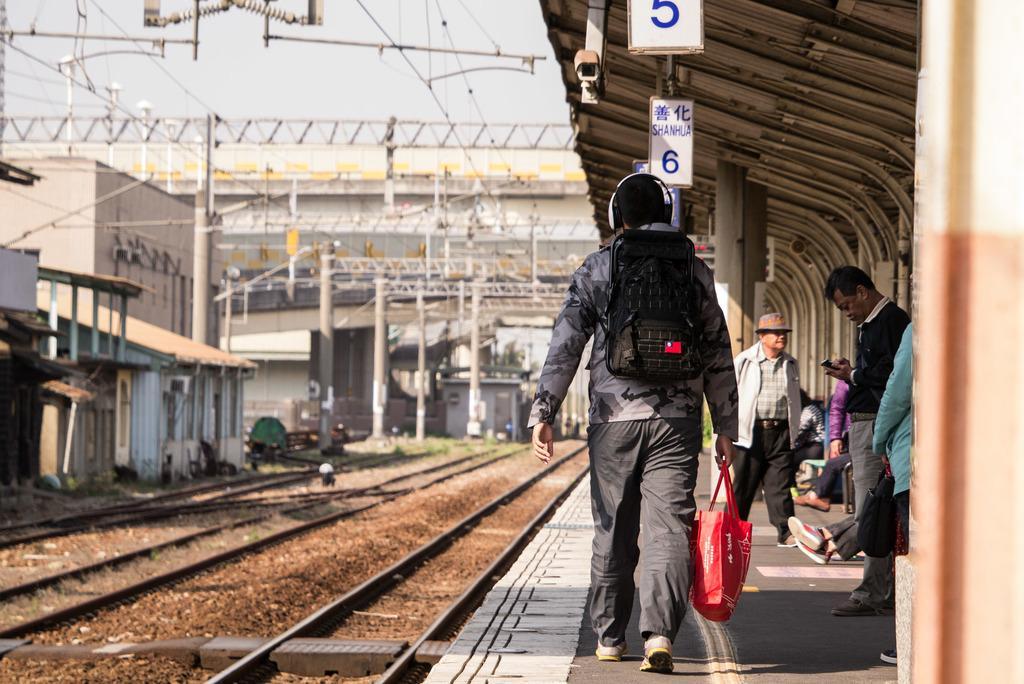Can you describe this image briefly? In this picture I can see the platform in front on which there are number of people and on the right top of this image I see the shed and I see boards on which there is something written. On the left bottom of this image I see the tracks and in the background I see number of poles, rods, wires and buildings and I can also see that, the man in the front is carrying bags. 